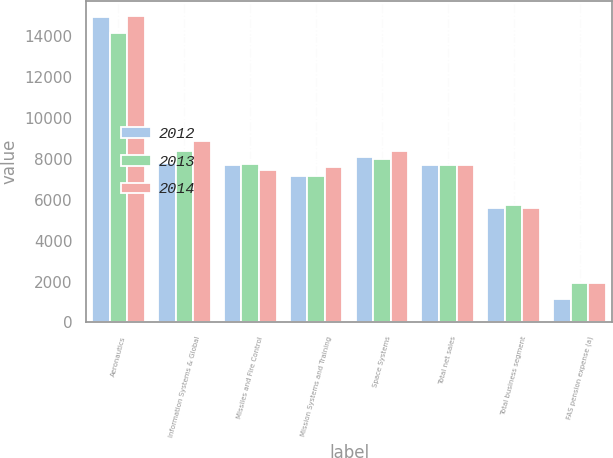<chart> <loc_0><loc_0><loc_500><loc_500><stacked_bar_chart><ecel><fcel>Aeronautics<fcel>Information Systems & Global<fcel>Missiles and Fire Control<fcel>Mission Systems and Training<fcel>Space Systems<fcel>Total net sales<fcel>Total business segment<fcel>FAS pension expense (a)<nl><fcel>2012<fcel>14920<fcel>7788<fcel>7680<fcel>7147<fcel>8065<fcel>7680<fcel>5588<fcel>1144<nl><fcel>2013<fcel>14123<fcel>8367<fcel>7757<fcel>7153<fcel>7958<fcel>7680<fcel>5752<fcel>1948<nl><fcel>2014<fcel>14953<fcel>8846<fcel>7457<fcel>7579<fcel>8347<fcel>7680<fcel>5583<fcel>1941<nl></chart> 